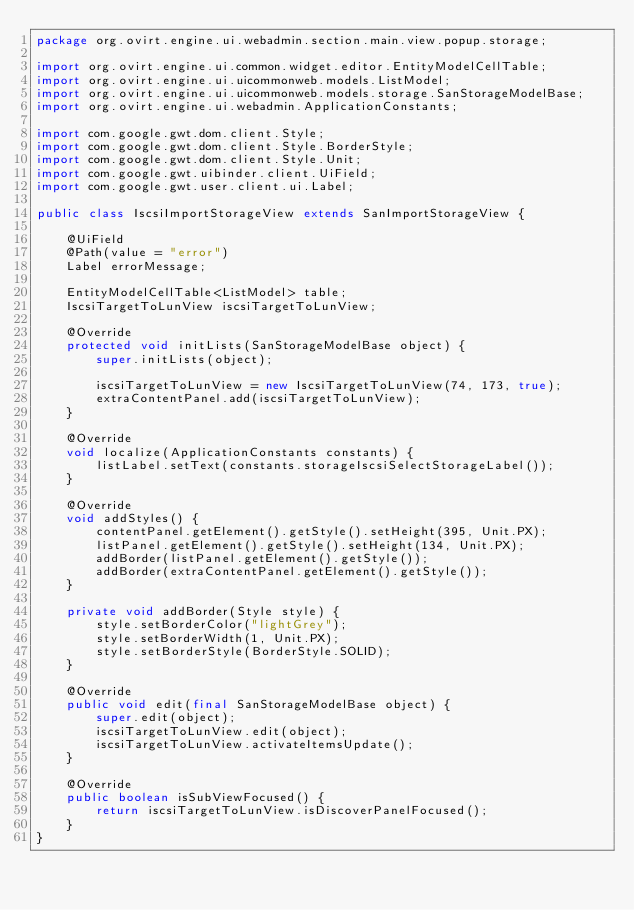Convert code to text. <code><loc_0><loc_0><loc_500><loc_500><_Java_>package org.ovirt.engine.ui.webadmin.section.main.view.popup.storage;

import org.ovirt.engine.ui.common.widget.editor.EntityModelCellTable;
import org.ovirt.engine.ui.uicommonweb.models.ListModel;
import org.ovirt.engine.ui.uicommonweb.models.storage.SanStorageModelBase;
import org.ovirt.engine.ui.webadmin.ApplicationConstants;

import com.google.gwt.dom.client.Style;
import com.google.gwt.dom.client.Style.BorderStyle;
import com.google.gwt.dom.client.Style.Unit;
import com.google.gwt.uibinder.client.UiField;
import com.google.gwt.user.client.ui.Label;

public class IscsiImportStorageView extends SanImportStorageView {

    @UiField
    @Path(value = "error")
    Label errorMessage;

    EntityModelCellTable<ListModel> table;
    IscsiTargetToLunView iscsiTargetToLunView;

    @Override
    protected void initLists(SanStorageModelBase object) {
        super.initLists(object);

        iscsiTargetToLunView = new IscsiTargetToLunView(74, 173, true);
        extraContentPanel.add(iscsiTargetToLunView);
    }

    @Override
    void localize(ApplicationConstants constants) {
        listLabel.setText(constants.storageIscsiSelectStorageLabel());
    }

    @Override
    void addStyles() {
        contentPanel.getElement().getStyle().setHeight(395, Unit.PX);
        listPanel.getElement().getStyle().setHeight(134, Unit.PX);
        addBorder(listPanel.getElement().getStyle());
        addBorder(extraContentPanel.getElement().getStyle());
    }

    private void addBorder(Style style) {
        style.setBorderColor("lightGrey");
        style.setBorderWidth(1, Unit.PX);
        style.setBorderStyle(BorderStyle.SOLID);
    }

    @Override
    public void edit(final SanStorageModelBase object) {
        super.edit(object);
        iscsiTargetToLunView.edit(object);
        iscsiTargetToLunView.activateItemsUpdate();
    }

    @Override
    public boolean isSubViewFocused() {
        return iscsiTargetToLunView.isDiscoverPanelFocused();
    }
}
</code> 